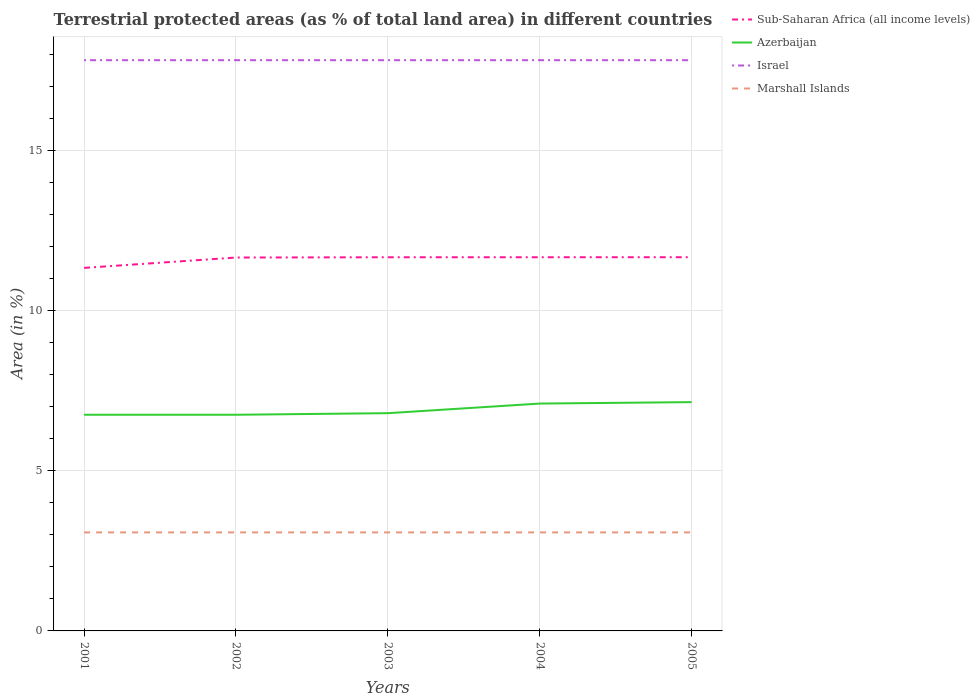How many different coloured lines are there?
Your response must be concise. 4. Is the number of lines equal to the number of legend labels?
Your response must be concise. Yes. Across all years, what is the maximum percentage of terrestrial protected land in Azerbaijan?
Your answer should be compact. 6.75. What is the total percentage of terrestrial protected land in Sub-Saharan Africa (all income levels) in the graph?
Offer a terse response. -0.32. What is the difference between the highest and the second highest percentage of terrestrial protected land in Marshall Islands?
Give a very brief answer. 0. What is the difference between the highest and the lowest percentage of terrestrial protected land in Marshall Islands?
Provide a short and direct response. 0. How many years are there in the graph?
Ensure brevity in your answer.  5. How many legend labels are there?
Ensure brevity in your answer.  4. What is the title of the graph?
Your answer should be compact. Terrestrial protected areas (as % of total land area) in different countries. What is the label or title of the Y-axis?
Ensure brevity in your answer.  Area (in %). What is the Area (in %) in Sub-Saharan Africa (all income levels) in 2001?
Offer a terse response. 11.34. What is the Area (in %) of Azerbaijan in 2001?
Ensure brevity in your answer.  6.75. What is the Area (in %) of Israel in 2001?
Your answer should be very brief. 17.83. What is the Area (in %) of Marshall Islands in 2001?
Your answer should be very brief. 3.08. What is the Area (in %) in Sub-Saharan Africa (all income levels) in 2002?
Ensure brevity in your answer.  11.67. What is the Area (in %) of Azerbaijan in 2002?
Your response must be concise. 6.75. What is the Area (in %) in Israel in 2002?
Keep it short and to the point. 17.83. What is the Area (in %) of Marshall Islands in 2002?
Keep it short and to the point. 3.08. What is the Area (in %) in Sub-Saharan Africa (all income levels) in 2003?
Your answer should be compact. 11.68. What is the Area (in %) in Azerbaijan in 2003?
Your response must be concise. 6.8. What is the Area (in %) in Israel in 2003?
Provide a short and direct response. 17.83. What is the Area (in %) of Marshall Islands in 2003?
Offer a terse response. 3.08. What is the Area (in %) of Sub-Saharan Africa (all income levels) in 2004?
Provide a short and direct response. 11.68. What is the Area (in %) in Azerbaijan in 2004?
Give a very brief answer. 7.1. What is the Area (in %) in Israel in 2004?
Keep it short and to the point. 17.83. What is the Area (in %) of Marshall Islands in 2004?
Offer a terse response. 3.08. What is the Area (in %) of Sub-Saharan Africa (all income levels) in 2005?
Ensure brevity in your answer.  11.68. What is the Area (in %) in Azerbaijan in 2005?
Your answer should be very brief. 7.15. What is the Area (in %) of Israel in 2005?
Ensure brevity in your answer.  17.83. What is the Area (in %) in Marshall Islands in 2005?
Your answer should be compact. 3.08. Across all years, what is the maximum Area (in %) of Sub-Saharan Africa (all income levels)?
Ensure brevity in your answer.  11.68. Across all years, what is the maximum Area (in %) in Azerbaijan?
Offer a terse response. 7.15. Across all years, what is the maximum Area (in %) of Israel?
Provide a short and direct response. 17.83. Across all years, what is the maximum Area (in %) of Marshall Islands?
Give a very brief answer. 3.08. Across all years, what is the minimum Area (in %) in Sub-Saharan Africa (all income levels)?
Your answer should be compact. 11.34. Across all years, what is the minimum Area (in %) of Azerbaijan?
Keep it short and to the point. 6.75. Across all years, what is the minimum Area (in %) of Israel?
Give a very brief answer. 17.83. Across all years, what is the minimum Area (in %) of Marshall Islands?
Make the answer very short. 3.08. What is the total Area (in %) of Sub-Saharan Africa (all income levels) in the graph?
Ensure brevity in your answer.  58.04. What is the total Area (in %) in Azerbaijan in the graph?
Provide a short and direct response. 34.57. What is the total Area (in %) of Israel in the graph?
Your response must be concise. 89.17. What is the total Area (in %) of Marshall Islands in the graph?
Ensure brevity in your answer.  15.39. What is the difference between the Area (in %) of Sub-Saharan Africa (all income levels) in 2001 and that in 2002?
Give a very brief answer. -0.32. What is the difference between the Area (in %) of Azerbaijan in 2001 and that in 2002?
Your answer should be very brief. 0. What is the difference between the Area (in %) of Israel in 2001 and that in 2002?
Provide a succinct answer. 0. What is the difference between the Area (in %) in Marshall Islands in 2001 and that in 2002?
Ensure brevity in your answer.  0. What is the difference between the Area (in %) of Sub-Saharan Africa (all income levels) in 2001 and that in 2003?
Provide a succinct answer. -0.33. What is the difference between the Area (in %) in Azerbaijan in 2001 and that in 2003?
Your answer should be compact. -0.05. What is the difference between the Area (in %) of Marshall Islands in 2001 and that in 2003?
Your answer should be compact. 0. What is the difference between the Area (in %) of Sub-Saharan Africa (all income levels) in 2001 and that in 2004?
Provide a succinct answer. -0.33. What is the difference between the Area (in %) in Azerbaijan in 2001 and that in 2004?
Provide a succinct answer. -0.35. What is the difference between the Area (in %) in Israel in 2001 and that in 2004?
Provide a succinct answer. 0. What is the difference between the Area (in %) of Sub-Saharan Africa (all income levels) in 2001 and that in 2005?
Provide a short and direct response. -0.33. What is the difference between the Area (in %) of Azerbaijan in 2001 and that in 2005?
Give a very brief answer. -0.39. What is the difference between the Area (in %) of Sub-Saharan Africa (all income levels) in 2002 and that in 2003?
Give a very brief answer. -0.01. What is the difference between the Area (in %) in Azerbaijan in 2002 and that in 2003?
Provide a short and direct response. -0.05. What is the difference between the Area (in %) in Israel in 2002 and that in 2003?
Make the answer very short. 0. What is the difference between the Area (in %) of Sub-Saharan Africa (all income levels) in 2002 and that in 2004?
Provide a short and direct response. -0.01. What is the difference between the Area (in %) in Azerbaijan in 2002 and that in 2004?
Provide a short and direct response. -0.35. What is the difference between the Area (in %) in Israel in 2002 and that in 2004?
Your answer should be compact. 0. What is the difference between the Area (in %) of Marshall Islands in 2002 and that in 2004?
Offer a terse response. 0. What is the difference between the Area (in %) in Sub-Saharan Africa (all income levels) in 2002 and that in 2005?
Ensure brevity in your answer.  -0.01. What is the difference between the Area (in %) in Azerbaijan in 2002 and that in 2005?
Provide a short and direct response. -0.39. What is the difference between the Area (in %) in Israel in 2002 and that in 2005?
Your response must be concise. 0. What is the difference between the Area (in %) of Marshall Islands in 2002 and that in 2005?
Offer a very short reply. 0. What is the difference between the Area (in %) in Sub-Saharan Africa (all income levels) in 2003 and that in 2004?
Give a very brief answer. -0. What is the difference between the Area (in %) in Azerbaijan in 2003 and that in 2004?
Ensure brevity in your answer.  -0.3. What is the difference between the Area (in %) of Israel in 2003 and that in 2004?
Offer a very short reply. 0. What is the difference between the Area (in %) in Sub-Saharan Africa (all income levels) in 2003 and that in 2005?
Make the answer very short. -0. What is the difference between the Area (in %) of Azerbaijan in 2003 and that in 2005?
Provide a succinct answer. -0.35. What is the difference between the Area (in %) of Israel in 2003 and that in 2005?
Your answer should be compact. 0. What is the difference between the Area (in %) in Marshall Islands in 2003 and that in 2005?
Offer a terse response. 0. What is the difference between the Area (in %) of Sub-Saharan Africa (all income levels) in 2004 and that in 2005?
Your answer should be compact. -0. What is the difference between the Area (in %) of Azerbaijan in 2004 and that in 2005?
Your answer should be compact. -0.04. What is the difference between the Area (in %) in Sub-Saharan Africa (all income levels) in 2001 and the Area (in %) in Azerbaijan in 2002?
Your answer should be compact. 4.59. What is the difference between the Area (in %) of Sub-Saharan Africa (all income levels) in 2001 and the Area (in %) of Israel in 2002?
Give a very brief answer. -6.49. What is the difference between the Area (in %) in Sub-Saharan Africa (all income levels) in 2001 and the Area (in %) in Marshall Islands in 2002?
Your response must be concise. 8.27. What is the difference between the Area (in %) of Azerbaijan in 2001 and the Area (in %) of Israel in 2002?
Provide a short and direct response. -11.08. What is the difference between the Area (in %) of Azerbaijan in 2001 and the Area (in %) of Marshall Islands in 2002?
Keep it short and to the point. 3.68. What is the difference between the Area (in %) in Israel in 2001 and the Area (in %) in Marshall Islands in 2002?
Provide a short and direct response. 14.76. What is the difference between the Area (in %) of Sub-Saharan Africa (all income levels) in 2001 and the Area (in %) of Azerbaijan in 2003?
Offer a very short reply. 4.54. What is the difference between the Area (in %) in Sub-Saharan Africa (all income levels) in 2001 and the Area (in %) in Israel in 2003?
Provide a succinct answer. -6.49. What is the difference between the Area (in %) in Sub-Saharan Africa (all income levels) in 2001 and the Area (in %) in Marshall Islands in 2003?
Keep it short and to the point. 8.27. What is the difference between the Area (in %) in Azerbaijan in 2001 and the Area (in %) in Israel in 2003?
Your answer should be compact. -11.08. What is the difference between the Area (in %) of Azerbaijan in 2001 and the Area (in %) of Marshall Islands in 2003?
Make the answer very short. 3.68. What is the difference between the Area (in %) in Israel in 2001 and the Area (in %) in Marshall Islands in 2003?
Offer a very short reply. 14.76. What is the difference between the Area (in %) of Sub-Saharan Africa (all income levels) in 2001 and the Area (in %) of Azerbaijan in 2004?
Offer a terse response. 4.24. What is the difference between the Area (in %) of Sub-Saharan Africa (all income levels) in 2001 and the Area (in %) of Israel in 2004?
Your answer should be compact. -6.49. What is the difference between the Area (in %) in Sub-Saharan Africa (all income levels) in 2001 and the Area (in %) in Marshall Islands in 2004?
Provide a short and direct response. 8.27. What is the difference between the Area (in %) in Azerbaijan in 2001 and the Area (in %) in Israel in 2004?
Provide a short and direct response. -11.08. What is the difference between the Area (in %) in Azerbaijan in 2001 and the Area (in %) in Marshall Islands in 2004?
Offer a very short reply. 3.68. What is the difference between the Area (in %) of Israel in 2001 and the Area (in %) of Marshall Islands in 2004?
Your answer should be very brief. 14.76. What is the difference between the Area (in %) of Sub-Saharan Africa (all income levels) in 2001 and the Area (in %) of Azerbaijan in 2005?
Your response must be concise. 4.19. What is the difference between the Area (in %) of Sub-Saharan Africa (all income levels) in 2001 and the Area (in %) of Israel in 2005?
Your answer should be compact. -6.49. What is the difference between the Area (in %) in Sub-Saharan Africa (all income levels) in 2001 and the Area (in %) in Marshall Islands in 2005?
Offer a terse response. 8.27. What is the difference between the Area (in %) of Azerbaijan in 2001 and the Area (in %) of Israel in 2005?
Provide a short and direct response. -11.08. What is the difference between the Area (in %) in Azerbaijan in 2001 and the Area (in %) in Marshall Islands in 2005?
Ensure brevity in your answer.  3.68. What is the difference between the Area (in %) of Israel in 2001 and the Area (in %) of Marshall Islands in 2005?
Give a very brief answer. 14.76. What is the difference between the Area (in %) of Sub-Saharan Africa (all income levels) in 2002 and the Area (in %) of Azerbaijan in 2003?
Keep it short and to the point. 4.86. What is the difference between the Area (in %) of Sub-Saharan Africa (all income levels) in 2002 and the Area (in %) of Israel in 2003?
Your response must be concise. -6.17. What is the difference between the Area (in %) of Sub-Saharan Africa (all income levels) in 2002 and the Area (in %) of Marshall Islands in 2003?
Keep it short and to the point. 8.59. What is the difference between the Area (in %) of Azerbaijan in 2002 and the Area (in %) of Israel in 2003?
Ensure brevity in your answer.  -11.08. What is the difference between the Area (in %) in Azerbaijan in 2002 and the Area (in %) in Marshall Islands in 2003?
Your response must be concise. 3.68. What is the difference between the Area (in %) in Israel in 2002 and the Area (in %) in Marshall Islands in 2003?
Make the answer very short. 14.76. What is the difference between the Area (in %) in Sub-Saharan Africa (all income levels) in 2002 and the Area (in %) in Azerbaijan in 2004?
Make the answer very short. 4.56. What is the difference between the Area (in %) in Sub-Saharan Africa (all income levels) in 2002 and the Area (in %) in Israel in 2004?
Make the answer very short. -6.17. What is the difference between the Area (in %) in Sub-Saharan Africa (all income levels) in 2002 and the Area (in %) in Marshall Islands in 2004?
Provide a succinct answer. 8.59. What is the difference between the Area (in %) in Azerbaijan in 2002 and the Area (in %) in Israel in 2004?
Ensure brevity in your answer.  -11.08. What is the difference between the Area (in %) of Azerbaijan in 2002 and the Area (in %) of Marshall Islands in 2004?
Your answer should be compact. 3.68. What is the difference between the Area (in %) of Israel in 2002 and the Area (in %) of Marshall Islands in 2004?
Your answer should be very brief. 14.76. What is the difference between the Area (in %) of Sub-Saharan Africa (all income levels) in 2002 and the Area (in %) of Azerbaijan in 2005?
Offer a very short reply. 4.52. What is the difference between the Area (in %) of Sub-Saharan Africa (all income levels) in 2002 and the Area (in %) of Israel in 2005?
Ensure brevity in your answer.  -6.17. What is the difference between the Area (in %) of Sub-Saharan Africa (all income levels) in 2002 and the Area (in %) of Marshall Islands in 2005?
Provide a succinct answer. 8.59. What is the difference between the Area (in %) of Azerbaijan in 2002 and the Area (in %) of Israel in 2005?
Give a very brief answer. -11.08. What is the difference between the Area (in %) in Azerbaijan in 2002 and the Area (in %) in Marshall Islands in 2005?
Give a very brief answer. 3.68. What is the difference between the Area (in %) of Israel in 2002 and the Area (in %) of Marshall Islands in 2005?
Your answer should be compact. 14.76. What is the difference between the Area (in %) of Sub-Saharan Africa (all income levels) in 2003 and the Area (in %) of Azerbaijan in 2004?
Your answer should be very brief. 4.57. What is the difference between the Area (in %) in Sub-Saharan Africa (all income levels) in 2003 and the Area (in %) in Israel in 2004?
Your answer should be compact. -6.16. What is the difference between the Area (in %) of Sub-Saharan Africa (all income levels) in 2003 and the Area (in %) of Marshall Islands in 2004?
Your answer should be compact. 8.6. What is the difference between the Area (in %) of Azerbaijan in 2003 and the Area (in %) of Israel in 2004?
Your answer should be very brief. -11.03. What is the difference between the Area (in %) of Azerbaijan in 2003 and the Area (in %) of Marshall Islands in 2004?
Give a very brief answer. 3.73. What is the difference between the Area (in %) of Israel in 2003 and the Area (in %) of Marshall Islands in 2004?
Provide a succinct answer. 14.76. What is the difference between the Area (in %) in Sub-Saharan Africa (all income levels) in 2003 and the Area (in %) in Azerbaijan in 2005?
Provide a succinct answer. 4.53. What is the difference between the Area (in %) of Sub-Saharan Africa (all income levels) in 2003 and the Area (in %) of Israel in 2005?
Offer a terse response. -6.16. What is the difference between the Area (in %) of Sub-Saharan Africa (all income levels) in 2003 and the Area (in %) of Marshall Islands in 2005?
Your response must be concise. 8.6. What is the difference between the Area (in %) of Azerbaijan in 2003 and the Area (in %) of Israel in 2005?
Give a very brief answer. -11.03. What is the difference between the Area (in %) of Azerbaijan in 2003 and the Area (in %) of Marshall Islands in 2005?
Offer a very short reply. 3.73. What is the difference between the Area (in %) in Israel in 2003 and the Area (in %) in Marshall Islands in 2005?
Provide a succinct answer. 14.76. What is the difference between the Area (in %) in Sub-Saharan Africa (all income levels) in 2004 and the Area (in %) in Azerbaijan in 2005?
Provide a succinct answer. 4.53. What is the difference between the Area (in %) of Sub-Saharan Africa (all income levels) in 2004 and the Area (in %) of Israel in 2005?
Ensure brevity in your answer.  -6.16. What is the difference between the Area (in %) of Sub-Saharan Africa (all income levels) in 2004 and the Area (in %) of Marshall Islands in 2005?
Provide a succinct answer. 8.6. What is the difference between the Area (in %) of Azerbaijan in 2004 and the Area (in %) of Israel in 2005?
Your answer should be compact. -10.73. What is the difference between the Area (in %) in Azerbaijan in 2004 and the Area (in %) in Marshall Islands in 2005?
Your answer should be very brief. 4.03. What is the difference between the Area (in %) of Israel in 2004 and the Area (in %) of Marshall Islands in 2005?
Make the answer very short. 14.76. What is the average Area (in %) of Sub-Saharan Africa (all income levels) per year?
Provide a short and direct response. 11.61. What is the average Area (in %) of Azerbaijan per year?
Ensure brevity in your answer.  6.91. What is the average Area (in %) in Israel per year?
Make the answer very short. 17.83. What is the average Area (in %) in Marshall Islands per year?
Your response must be concise. 3.08. In the year 2001, what is the difference between the Area (in %) in Sub-Saharan Africa (all income levels) and Area (in %) in Azerbaijan?
Offer a terse response. 4.59. In the year 2001, what is the difference between the Area (in %) in Sub-Saharan Africa (all income levels) and Area (in %) in Israel?
Ensure brevity in your answer.  -6.49. In the year 2001, what is the difference between the Area (in %) in Sub-Saharan Africa (all income levels) and Area (in %) in Marshall Islands?
Your answer should be compact. 8.27. In the year 2001, what is the difference between the Area (in %) in Azerbaijan and Area (in %) in Israel?
Your answer should be very brief. -11.08. In the year 2001, what is the difference between the Area (in %) in Azerbaijan and Area (in %) in Marshall Islands?
Your answer should be compact. 3.68. In the year 2001, what is the difference between the Area (in %) in Israel and Area (in %) in Marshall Islands?
Provide a succinct answer. 14.76. In the year 2002, what is the difference between the Area (in %) in Sub-Saharan Africa (all income levels) and Area (in %) in Azerbaijan?
Your response must be concise. 4.91. In the year 2002, what is the difference between the Area (in %) of Sub-Saharan Africa (all income levels) and Area (in %) of Israel?
Provide a short and direct response. -6.17. In the year 2002, what is the difference between the Area (in %) in Sub-Saharan Africa (all income levels) and Area (in %) in Marshall Islands?
Offer a very short reply. 8.59. In the year 2002, what is the difference between the Area (in %) of Azerbaijan and Area (in %) of Israel?
Your response must be concise. -11.08. In the year 2002, what is the difference between the Area (in %) of Azerbaijan and Area (in %) of Marshall Islands?
Keep it short and to the point. 3.68. In the year 2002, what is the difference between the Area (in %) in Israel and Area (in %) in Marshall Islands?
Ensure brevity in your answer.  14.76. In the year 2003, what is the difference between the Area (in %) of Sub-Saharan Africa (all income levels) and Area (in %) of Azerbaijan?
Your response must be concise. 4.87. In the year 2003, what is the difference between the Area (in %) in Sub-Saharan Africa (all income levels) and Area (in %) in Israel?
Your answer should be compact. -6.16. In the year 2003, what is the difference between the Area (in %) in Sub-Saharan Africa (all income levels) and Area (in %) in Marshall Islands?
Offer a terse response. 8.6. In the year 2003, what is the difference between the Area (in %) in Azerbaijan and Area (in %) in Israel?
Offer a terse response. -11.03. In the year 2003, what is the difference between the Area (in %) in Azerbaijan and Area (in %) in Marshall Islands?
Give a very brief answer. 3.73. In the year 2003, what is the difference between the Area (in %) of Israel and Area (in %) of Marshall Islands?
Ensure brevity in your answer.  14.76. In the year 2004, what is the difference between the Area (in %) in Sub-Saharan Africa (all income levels) and Area (in %) in Azerbaijan?
Your answer should be very brief. 4.57. In the year 2004, what is the difference between the Area (in %) in Sub-Saharan Africa (all income levels) and Area (in %) in Israel?
Your answer should be compact. -6.16. In the year 2004, what is the difference between the Area (in %) in Sub-Saharan Africa (all income levels) and Area (in %) in Marshall Islands?
Provide a short and direct response. 8.6. In the year 2004, what is the difference between the Area (in %) in Azerbaijan and Area (in %) in Israel?
Give a very brief answer. -10.73. In the year 2004, what is the difference between the Area (in %) in Azerbaijan and Area (in %) in Marshall Islands?
Keep it short and to the point. 4.03. In the year 2004, what is the difference between the Area (in %) of Israel and Area (in %) of Marshall Islands?
Ensure brevity in your answer.  14.76. In the year 2005, what is the difference between the Area (in %) of Sub-Saharan Africa (all income levels) and Area (in %) of Azerbaijan?
Provide a short and direct response. 4.53. In the year 2005, what is the difference between the Area (in %) of Sub-Saharan Africa (all income levels) and Area (in %) of Israel?
Ensure brevity in your answer.  -6.16. In the year 2005, what is the difference between the Area (in %) in Sub-Saharan Africa (all income levels) and Area (in %) in Marshall Islands?
Ensure brevity in your answer.  8.6. In the year 2005, what is the difference between the Area (in %) in Azerbaijan and Area (in %) in Israel?
Offer a very short reply. -10.69. In the year 2005, what is the difference between the Area (in %) of Azerbaijan and Area (in %) of Marshall Islands?
Ensure brevity in your answer.  4.07. In the year 2005, what is the difference between the Area (in %) of Israel and Area (in %) of Marshall Islands?
Ensure brevity in your answer.  14.76. What is the ratio of the Area (in %) in Sub-Saharan Africa (all income levels) in 2001 to that in 2002?
Offer a very short reply. 0.97. What is the ratio of the Area (in %) in Israel in 2001 to that in 2002?
Ensure brevity in your answer.  1. What is the ratio of the Area (in %) in Sub-Saharan Africa (all income levels) in 2001 to that in 2003?
Provide a short and direct response. 0.97. What is the ratio of the Area (in %) in Israel in 2001 to that in 2003?
Give a very brief answer. 1. What is the ratio of the Area (in %) of Sub-Saharan Africa (all income levels) in 2001 to that in 2004?
Your response must be concise. 0.97. What is the ratio of the Area (in %) of Azerbaijan in 2001 to that in 2004?
Your answer should be compact. 0.95. What is the ratio of the Area (in %) in Israel in 2001 to that in 2004?
Provide a succinct answer. 1. What is the ratio of the Area (in %) in Marshall Islands in 2001 to that in 2004?
Give a very brief answer. 1. What is the ratio of the Area (in %) of Sub-Saharan Africa (all income levels) in 2001 to that in 2005?
Your response must be concise. 0.97. What is the ratio of the Area (in %) in Azerbaijan in 2001 to that in 2005?
Provide a short and direct response. 0.94. What is the ratio of the Area (in %) of Sub-Saharan Africa (all income levels) in 2002 to that in 2003?
Your answer should be compact. 1. What is the ratio of the Area (in %) of Marshall Islands in 2002 to that in 2003?
Provide a succinct answer. 1. What is the ratio of the Area (in %) of Sub-Saharan Africa (all income levels) in 2002 to that in 2004?
Keep it short and to the point. 1. What is the ratio of the Area (in %) in Azerbaijan in 2002 to that in 2004?
Your answer should be very brief. 0.95. What is the ratio of the Area (in %) of Sub-Saharan Africa (all income levels) in 2002 to that in 2005?
Offer a terse response. 1. What is the ratio of the Area (in %) in Azerbaijan in 2002 to that in 2005?
Your answer should be compact. 0.94. What is the ratio of the Area (in %) in Sub-Saharan Africa (all income levels) in 2003 to that in 2004?
Keep it short and to the point. 1. What is the ratio of the Area (in %) of Azerbaijan in 2003 to that in 2004?
Your response must be concise. 0.96. What is the ratio of the Area (in %) of Marshall Islands in 2003 to that in 2004?
Your response must be concise. 1. What is the ratio of the Area (in %) of Azerbaijan in 2003 to that in 2005?
Ensure brevity in your answer.  0.95. What is the difference between the highest and the second highest Area (in %) of Sub-Saharan Africa (all income levels)?
Provide a short and direct response. 0. What is the difference between the highest and the second highest Area (in %) of Azerbaijan?
Provide a short and direct response. 0.04. What is the difference between the highest and the lowest Area (in %) of Sub-Saharan Africa (all income levels)?
Keep it short and to the point. 0.33. What is the difference between the highest and the lowest Area (in %) in Azerbaijan?
Provide a short and direct response. 0.39. What is the difference between the highest and the lowest Area (in %) of Marshall Islands?
Offer a terse response. 0. 